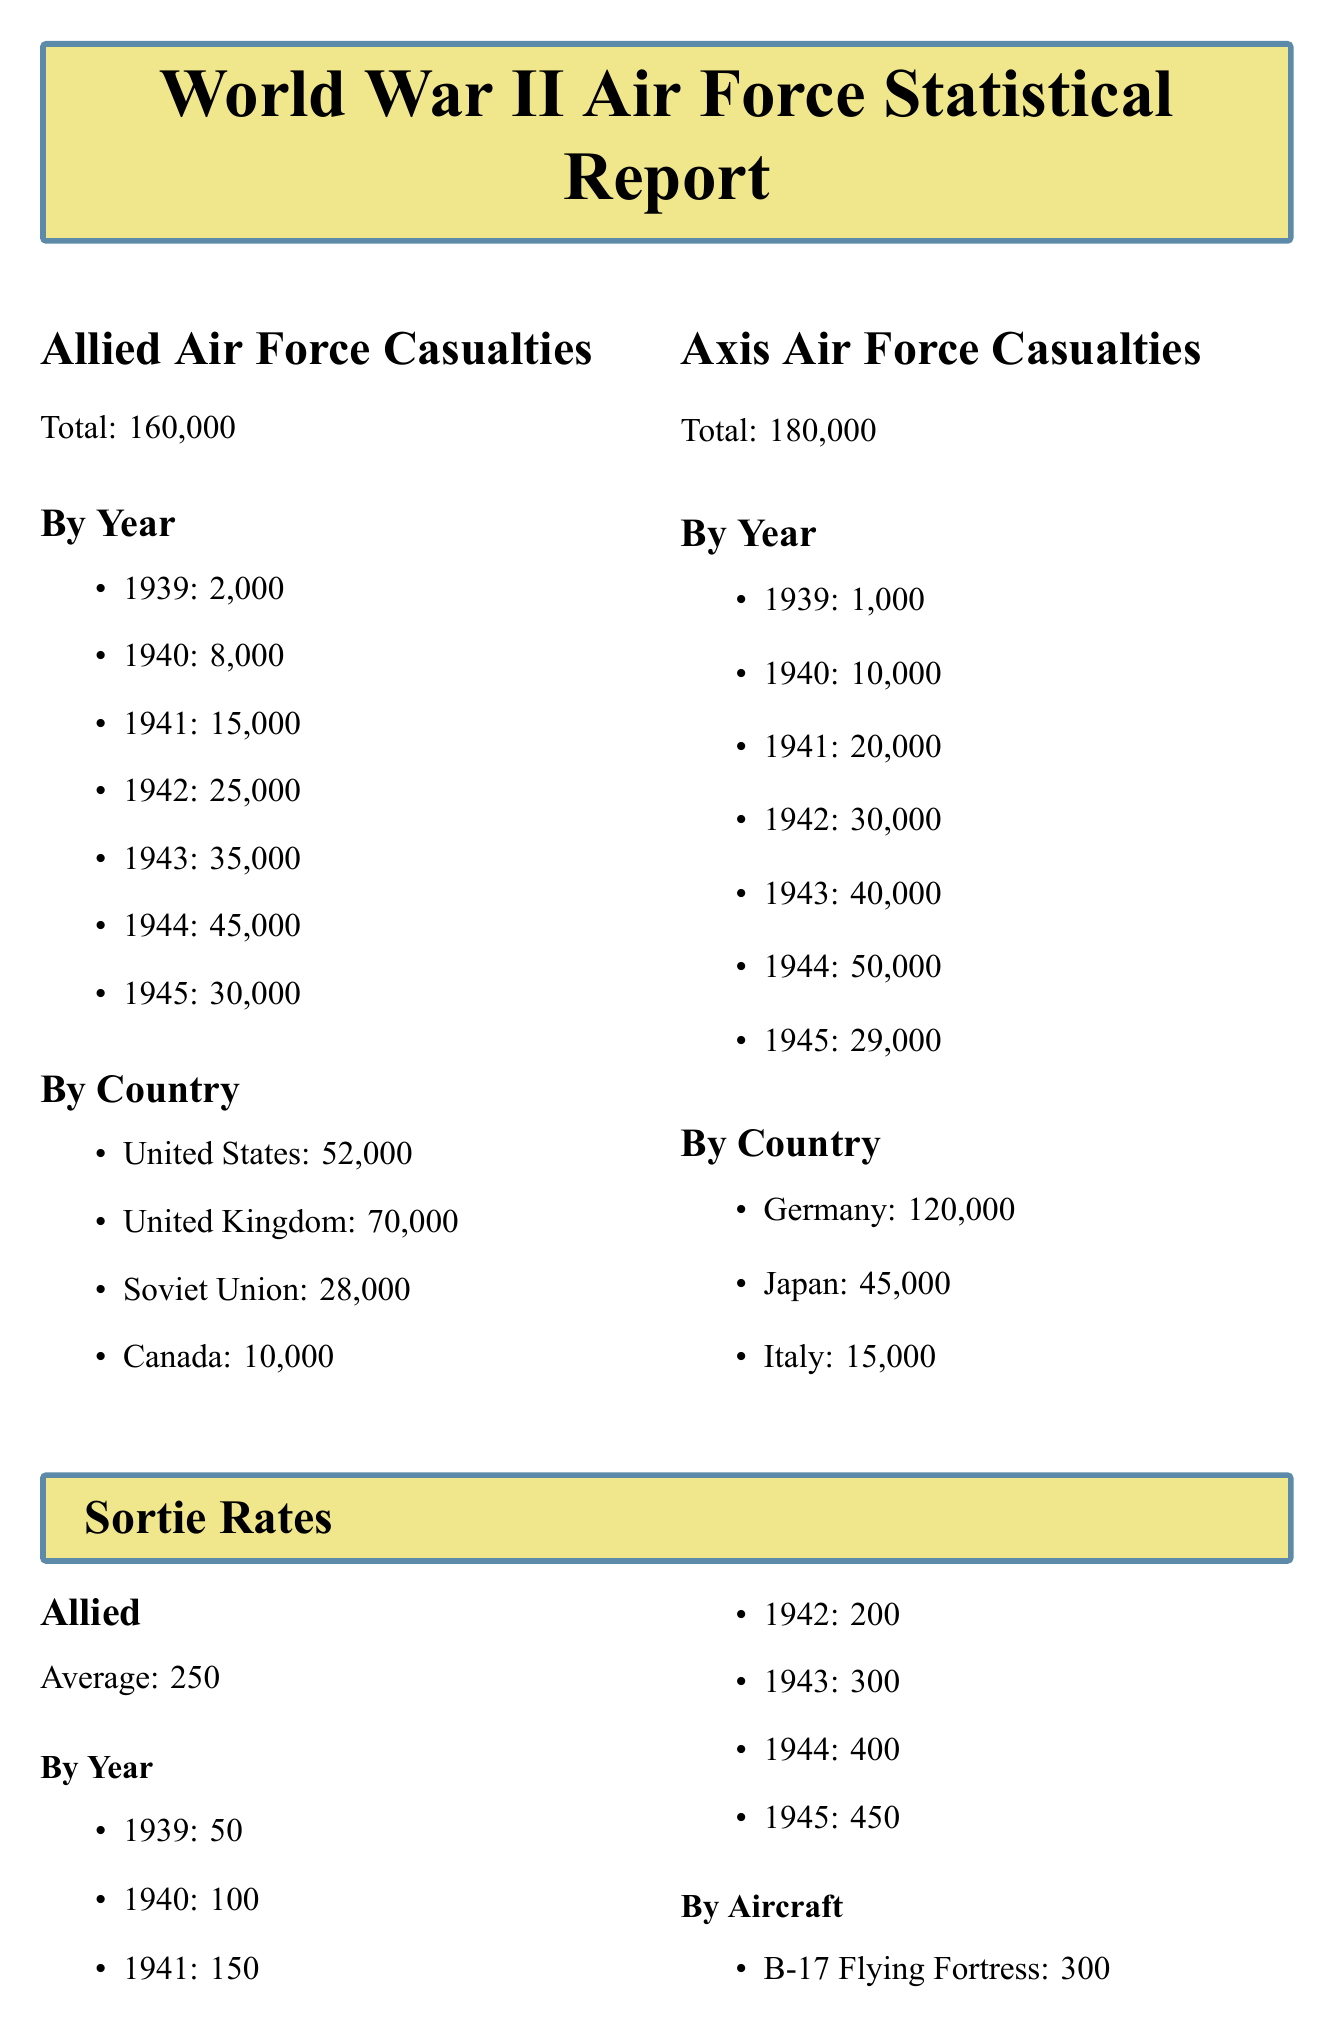What is the total number of Allied Air Force casualties? The total number of Allied Air Force casualties is mentioned in the document, which is 160,000.
Answer: 160,000 What was the Allied average sortie rate? The document specifies that the average sortie rate for the Allied Air Force is 250.
Answer: 250 Which country had the highest number of Axis Air Force casualties? The document indicates that Germany had the highest number of Axis Air Force casualties, totaling 120,000.
Answer: Germany What was the mission success rate for Operation Overlord? The document lists the mission success rate for Operation Overlord as 85%.
Answer: 85% How many sorties were flown by the P-51 Mustang? The sortie rate for the P-51 Mustang is mentioned in the document as 400.
Answer: 400 Which operation was mentioned as the most dangerous mission? The document states that the most dangerous mission was the Berlin raid in December 1943.
Answer: Berlin raid What year did the Axis Air Force casualties peak? According to the document, Axis Air Force casualties peaked in 1944 with 50,000 casualties.
Answer: 1944 What aircraft had the highest mission success rate among the Allies? The document notes that the De Havilland Mosquito had the highest mission success rate at 85%.
Answer: De Havilland Mosquito What was the total number of Allied Air Force casualties in 1943? The document states that in 1943 there were 35,000 Allied Air Force casualties.
Answer: 35,000 